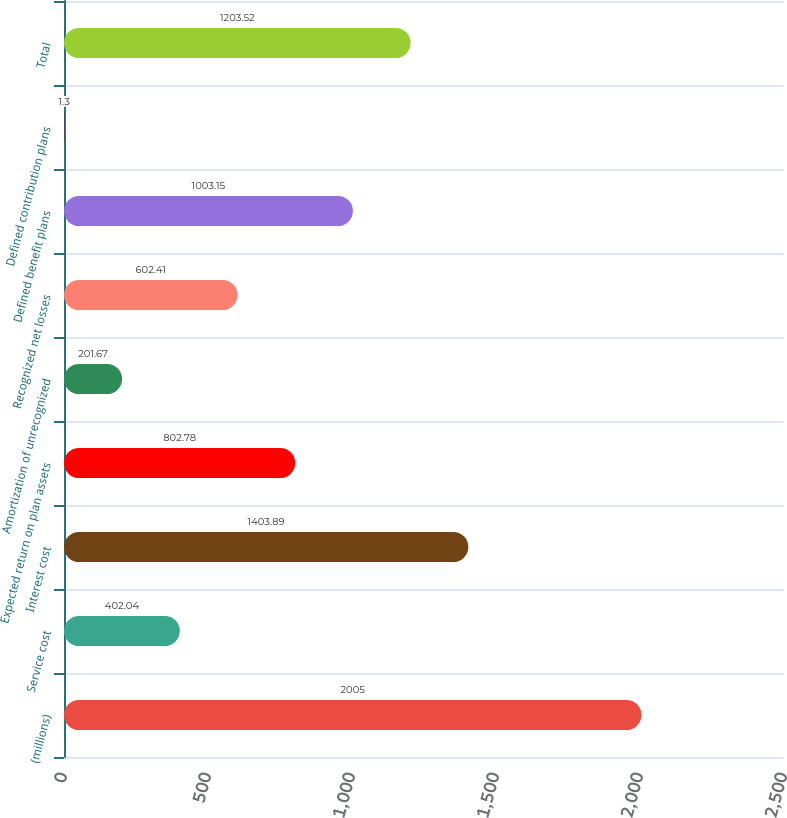<chart> <loc_0><loc_0><loc_500><loc_500><bar_chart><fcel>(millions)<fcel>Service cost<fcel>Interest cost<fcel>Expected return on plan assets<fcel>Amortization of unrecognized<fcel>Recognized net losses<fcel>Defined benefit plans<fcel>Defined contribution plans<fcel>Total<nl><fcel>2005<fcel>402.04<fcel>1403.89<fcel>802.78<fcel>201.67<fcel>602.41<fcel>1003.15<fcel>1.3<fcel>1203.52<nl></chart> 